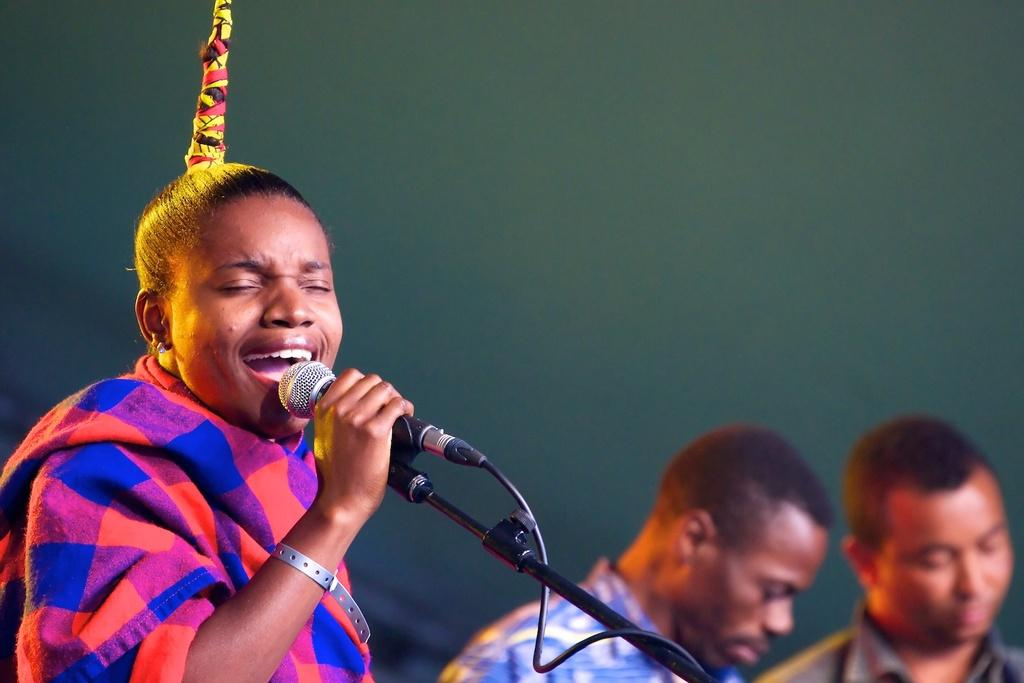What is the person in the image holding? The person is holding a microphone in the image. What is the person doing with the microphone? The person is singing while holding the microphone. How many other people are in the image besides the person with the microphone? There are two other persons in the image. What color is the background in the image? The background in the image is green. What type of key is being used to unlock the door in the image? There is no door or key present in the image; it features a person singing with a microphone and a green background. How many rays of sunshine can be seen illuminating the scene in the image? There are no rays of sunshine visible in the image; it has a green background. 